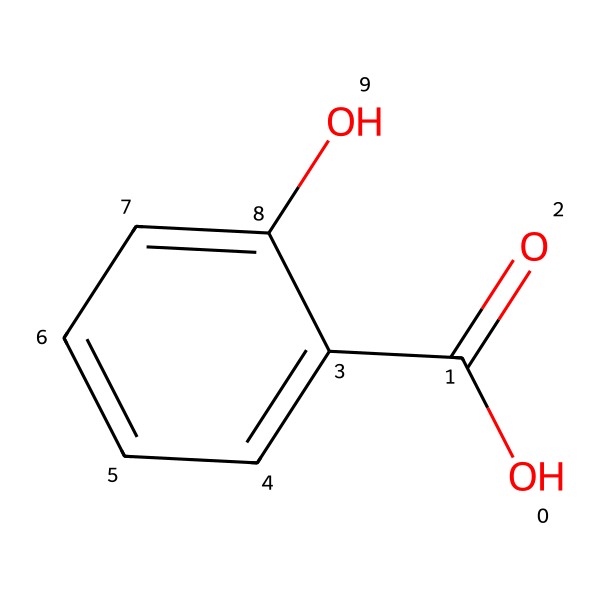What is the molecular formula of salicylic acid? The SMILES representation indicates the elements present and their counts. Breaking it down: one carbonyl (C=O), six carbons from the benzene ring (C), two oxygens (O), and four hydrogens (H). Thus, the formula is C7H6O3.
Answer: C7H6O3 How many aromatic carbons are present in the structure? The benzene ring in the chemical consists of six carbons, which are all part of the aromatic system, indicating that there are six aromatic carbons total.
Answer: 6 What functional groups are present in salicylic acid? Analyzing the structural elements, the compound contains a hydroxyl group (–OH) and a carboxyl group (–COOH). These identify it as having both phenolic and carboxylic characteristics.
Answer: hydroxyl and carboxyl Is salicylic acid polar or non-polar? The presence of polar functional groups, especially the hydroxyl and carboxyl groups, significantly increases the polarity of the molecule, making it polar overall.
Answer: polar Which part of salicylic acid is primarily responsible for its acne-fighting properties? The presence of the carboxylic acid group is crucial, as it contributes to the exfoliating properties of salicylic acid, allowing it to penetrate and clear pores, which is effective against acne.
Answer: carboxylic acid group 